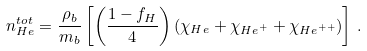Convert formula to latex. <formula><loc_0><loc_0><loc_500><loc_500>n _ { H e } ^ { t o t } = \frac { \rho _ { b } } { m _ { b } } \left [ \left ( \frac { 1 - f _ { H } } { 4 } \right ) ( \chi _ { H e } + \chi _ { { H e } ^ { + } } + \chi _ { { H e } ^ { + + } } ) \right ] \, .</formula> 